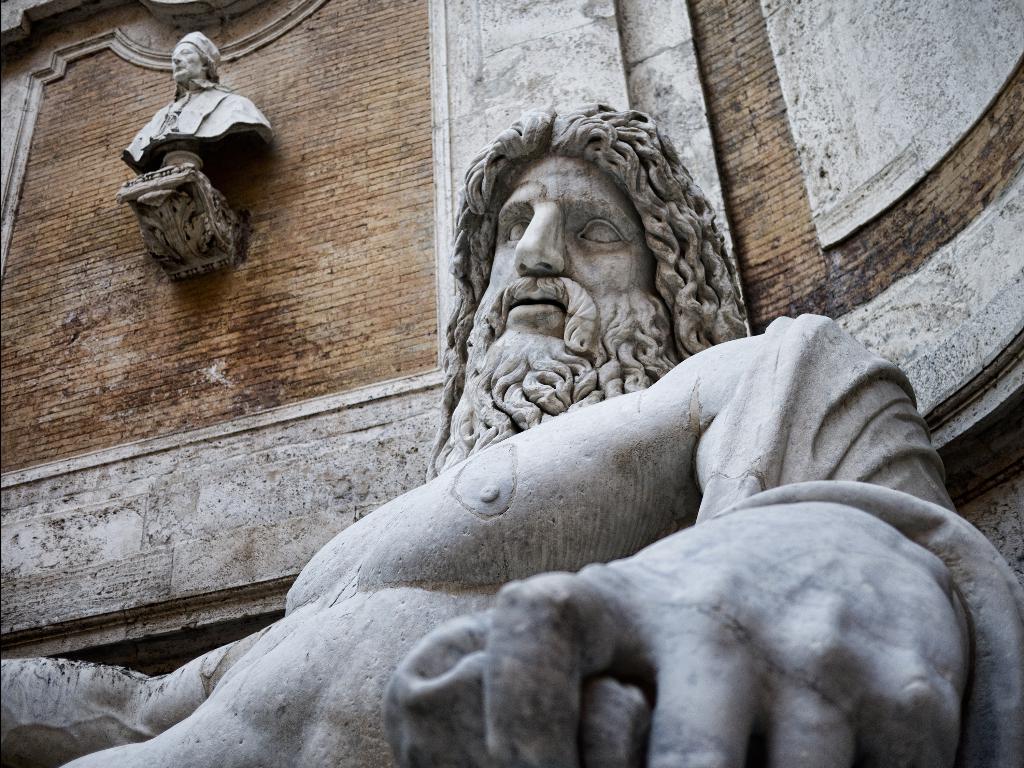Please provide a concise description of this image. In this picture we can see there are statues and wall. 